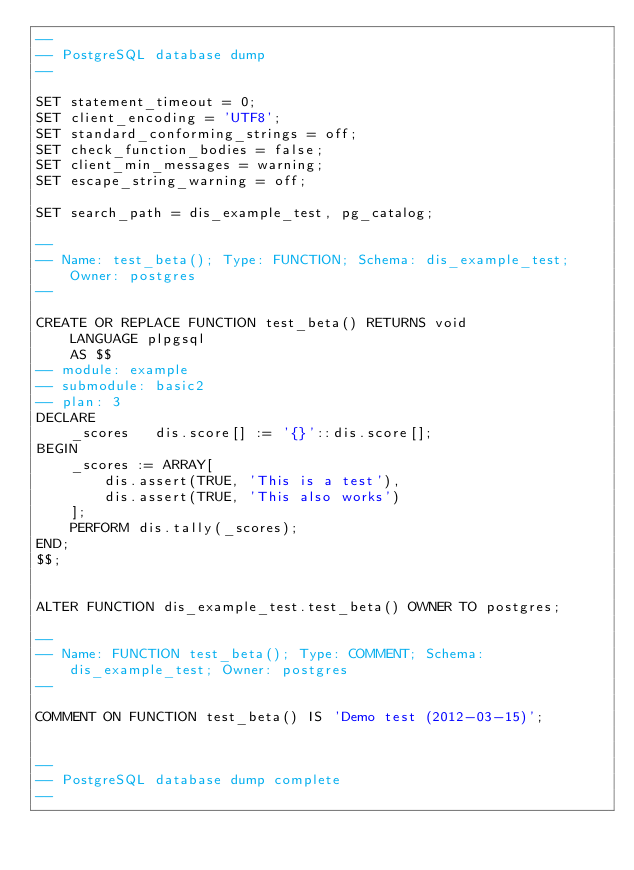Convert code to text. <code><loc_0><loc_0><loc_500><loc_500><_SQL_>--
-- PostgreSQL database dump
--

SET statement_timeout = 0;
SET client_encoding = 'UTF8';
SET standard_conforming_strings = off;
SET check_function_bodies = false;
SET client_min_messages = warning;
SET escape_string_warning = off;

SET search_path = dis_example_test, pg_catalog;

--
-- Name: test_beta(); Type: FUNCTION; Schema: dis_example_test; Owner: postgres
--

CREATE OR REPLACE FUNCTION test_beta() RETURNS void
    LANGUAGE plpgsql
    AS $$
-- module: example
-- submodule: basic2
-- plan: 3
DECLARE
    _scores   dis.score[] := '{}'::dis.score[];
BEGIN
    _scores := ARRAY[
        dis.assert(TRUE, 'This is a test'),
        dis.assert(TRUE, 'This also works')
    ];
    PERFORM dis.tally(_scores);
END;
$$;


ALTER FUNCTION dis_example_test.test_beta() OWNER TO postgres;

--
-- Name: FUNCTION test_beta(); Type: COMMENT; Schema: dis_example_test; Owner: postgres
--

COMMENT ON FUNCTION test_beta() IS 'Demo test (2012-03-15)';


--
-- PostgreSQL database dump complete
--

</code> 